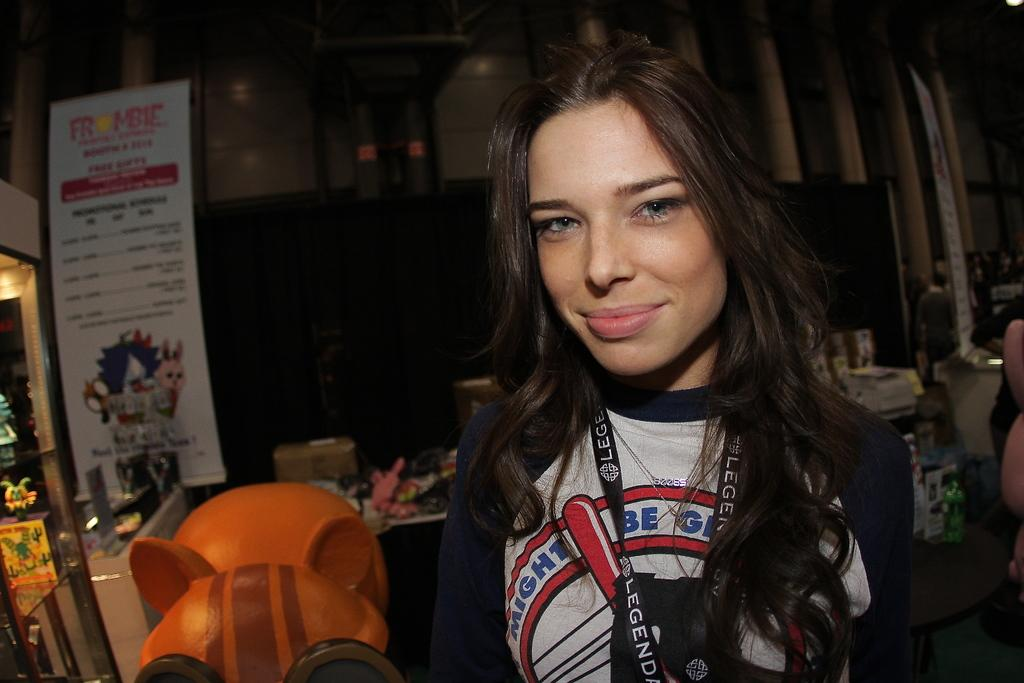Provide a one-sentence caption for the provided image. A woman standing in a store in front of a frombie sign. 